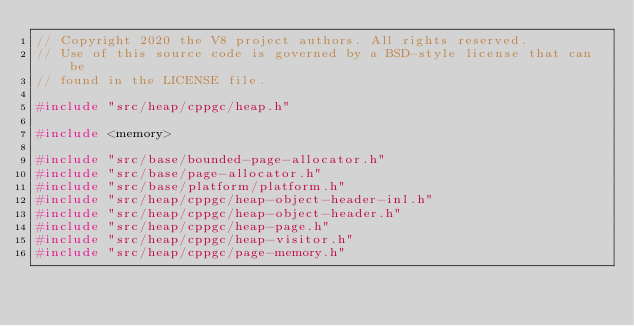Convert code to text. <code><loc_0><loc_0><loc_500><loc_500><_C++_>// Copyright 2020 the V8 project authors. All rights reserved.
// Use of this source code is governed by a BSD-style license that can be
// found in the LICENSE file.

#include "src/heap/cppgc/heap.h"

#include <memory>

#include "src/base/bounded-page-allocator.h"
#include "src/base/page-allocator.h"
#include "src/base/platform/platform.h"
#include "src/heap/cppgc/heap-object-header-inl.h"
#include "src/heap/cppgc/heap-object-header.h"
#include "src/heap/cppgc/heap-page.h"
#include "src/heap/cppgc/heap-visitor.h"
#include "src/heap/cppgc/page-memory.h"</code> 